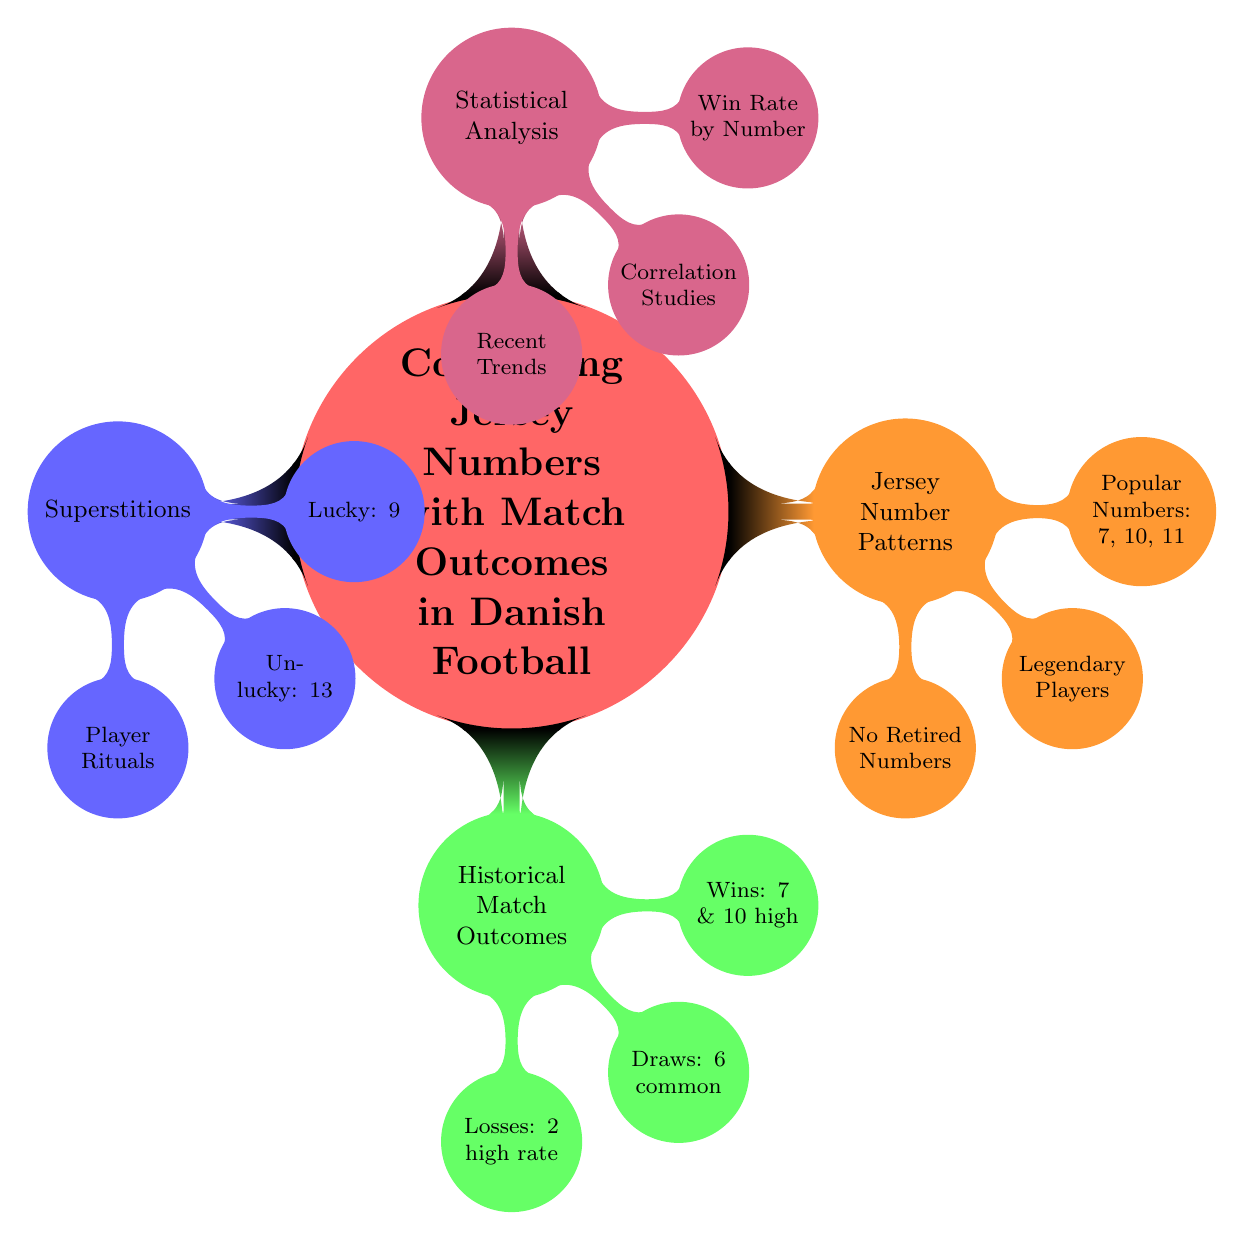What's the main topic of the diagram? The main topic is highlighted at the center of the diagram, clearly stating "Correlating Jersey Numbers with Match Outcomes in Danish Football." This is the primary focus of the mind map.
Answer: Correlating Jersey Numbers with Match Outcomes in Danish Football How many subtopics are in the diagram? There are four distinct subtopics branching out from the main topic: Jersey Number Patterns, Historical Match Outcomes, Superstitions, and Statistical Analysis. This is counted directly from the diagram's structure.
Answer: 4 Which jersey number is associated with the highest win rate? Within the subtopic Historical Match Outcomes, it is stated that number 7 has the highest win rate. This specific information is directly referenced in the relevant node.
Answer: Number 7 What is the common outcome associated with jersey number 6? The diagram indicates that number 6 is commonly found in draws, providing a clear connection to the Historical Match Outcomes subtopic.
Answer: Draws Which number is often avoided due to superstition? Under the Superstitions subtopic, it points out that the number 13 is often avoided by players, indicating its association with bad luck in this context.
Answer: 13 Which significant player wore jersey number 10? In the Jersey Number Patterns subtopic, the legendary player Michael Laudrup is specifically mentioned as an iconic figure associated with jersey number 10, confirming its historical importance.
Answer: Michael Laudrup (10) How does the document indicate the relationship between superstitions and jersey numbers? The diagram shows that the Superstitions subtopic includes associations of lucky and unlucky numbers, indicating how certain numbers impact player choices and beliefs, thus linking superstitions to jersey numbers directly.
Answer: Player Rituals What recent trends does the diagram suggest are analyzed? Under the Statistical Analysis subtopic, it mentions "Current season analysis,” indicating that recent performance trends related to jersey numbers are being evaluated.
Answer: Current season analysis Which jersey number is known to be associated with a high loss rate? The Historical Match Outcomes section indicates that players wearing jersey number 2 have a high loss rate, signifying a direct link to match performance outcomes.
Answer: Number 2 